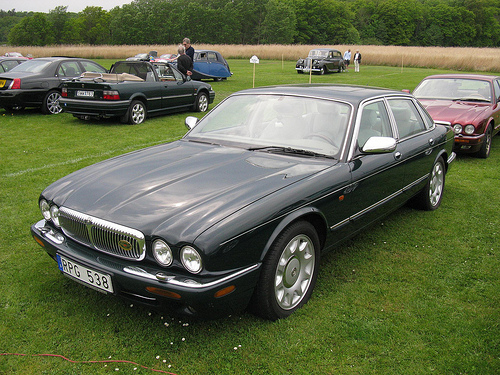<image>
Is the ground on the car? No. The ground is not positioned on the car. They may be near each other, but the ground is not supported by or resting on top of the car. 